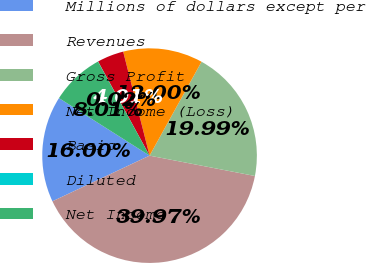Convert chart to OTSL. <chart><loc_0><loc_0><loc_500><loc_500><pie_chart><fcel>Millions of dollars except per<fcel>Revenues<fcel>Gross Profit<fcel>Net Income (Loss)<fcel>Basic<fcel>Diluted<fcel>Net Income<nl><fcel>16.0%<fcel>39.97%<fcel>19.99%<fcel>12.0%<fcel>4.01%<fcel>0.02%<fcel>8.01%<nl></chart> 